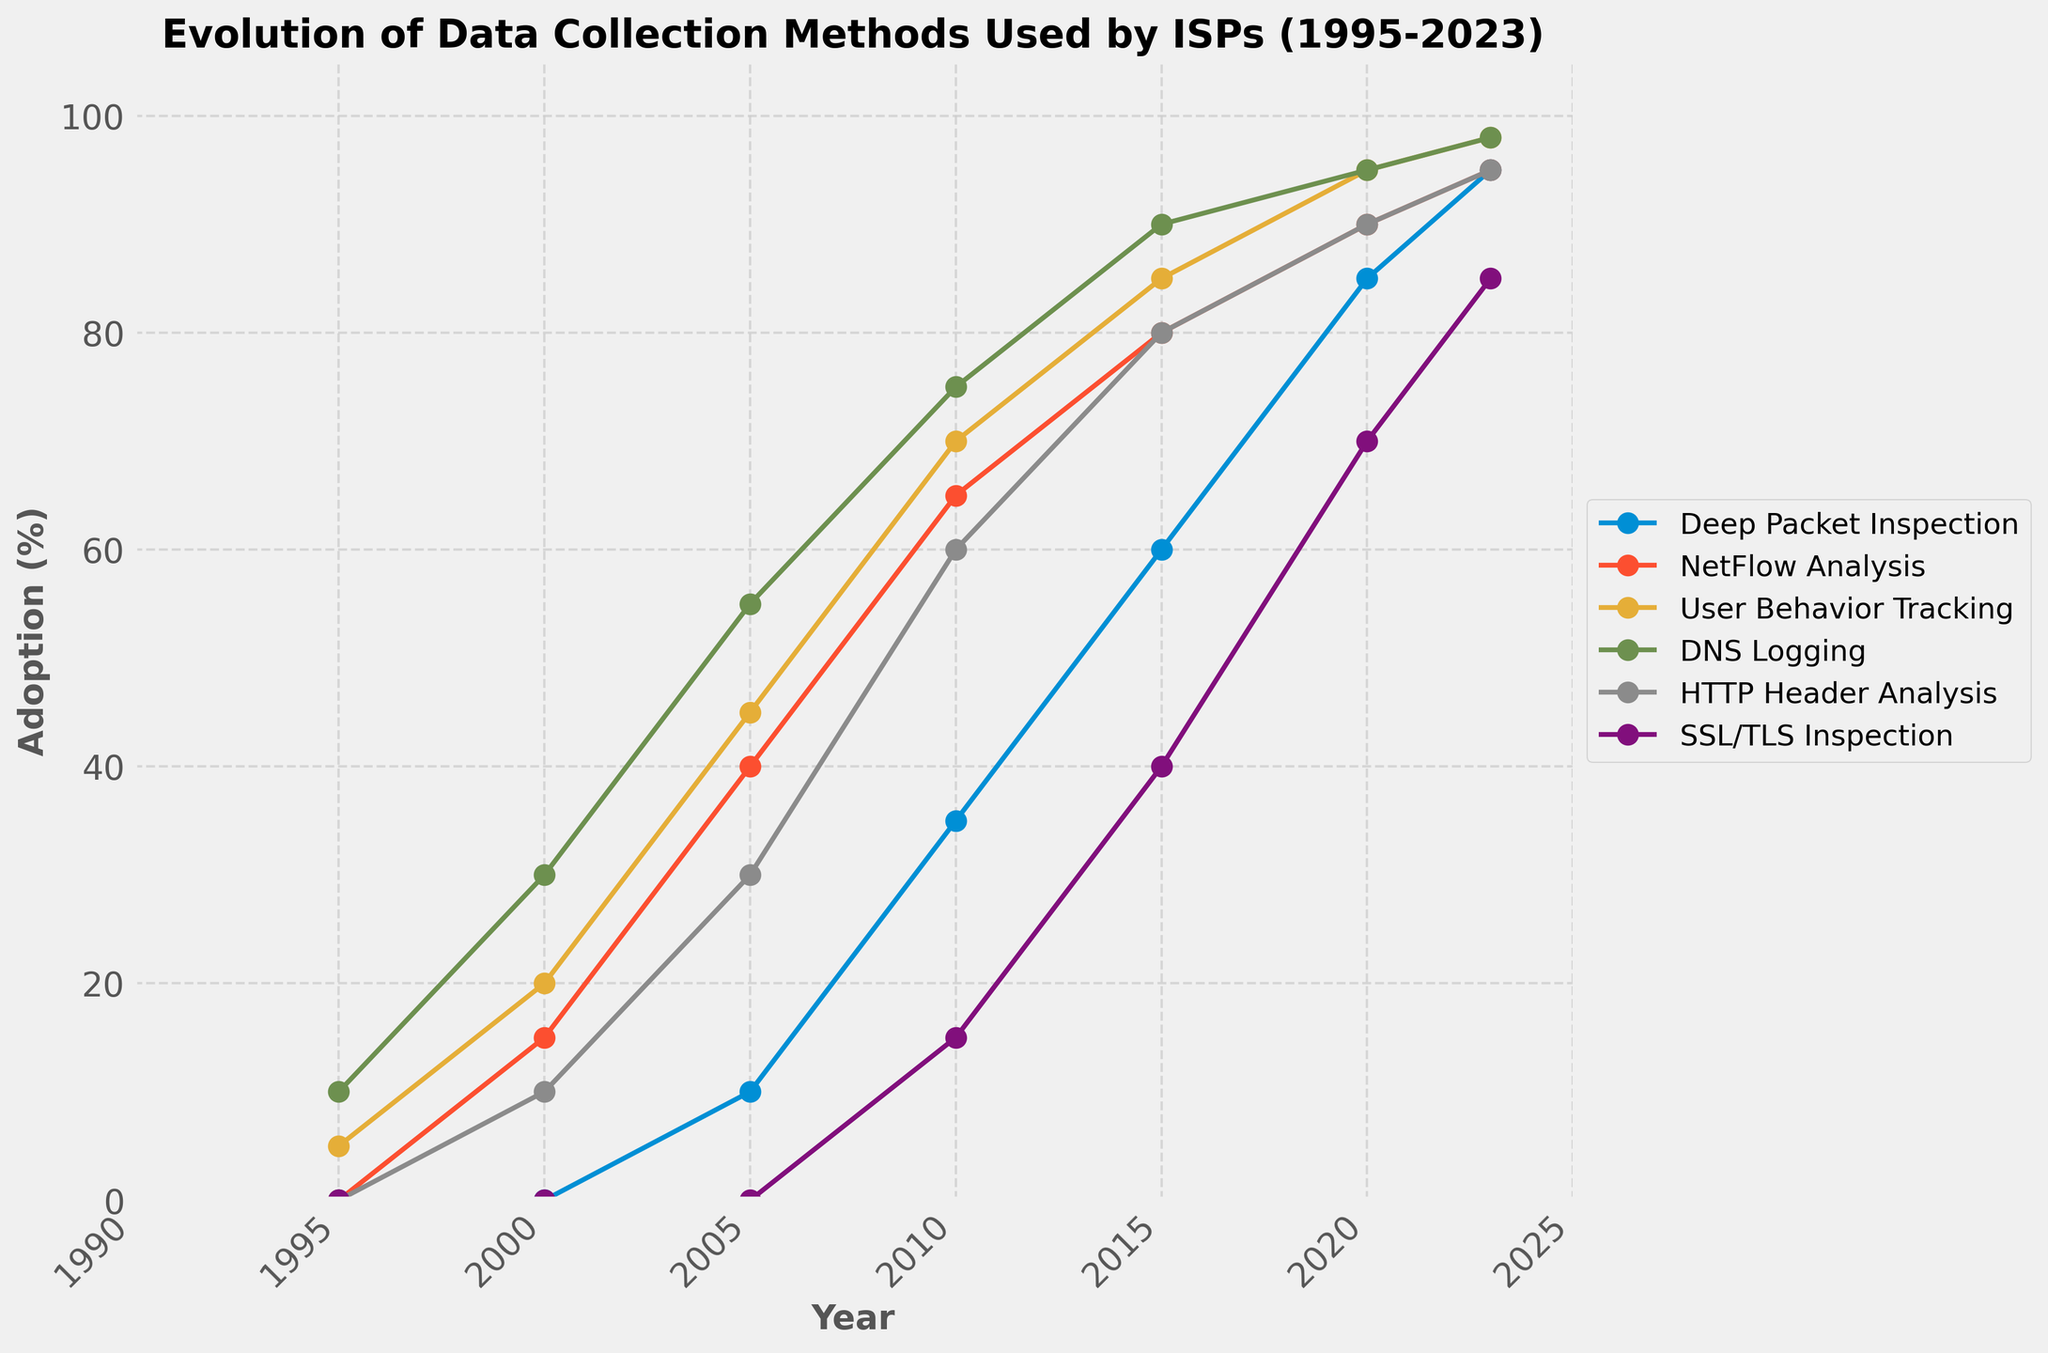What's the overall trend of Deep Packet Inspection from 1995 to 2023? To find the overall trend, observe the line for Deep Packet Inspection on the chart. The percentage starts at 0% in 1995 and increases steadily over time, reaching 95% by 2023.
Answer: Increasing Which data collection method had the highest adoption rate in 2010? Look at the values for each method in 2010 and compare them. Deep Packet Inspection (35%), NetFlow Analysis (65%), User Behavior Tracking (70%), DNS Logging (75%), HTTP Header Analysis (60%), and SSL/TLS Inspection (15%). DNS Logging has the highest adoption rate in 2010 at 75%.
Answer: DNS Logging How does the adoption of SSL/TLS Inspection in 2023 compare to that in 2005? Check the values for SSL/TLS Inspection in 2023 (85%) and 2005 (0%). The adoption significantly increased from 0% in 2005 to 85% in 2023.
Answer: Increased Which method experienced the smallest increase between 2000 and 2005? Calculate the difference for each method from 2000 to 2005: Deep Packet Inspection (10-0=10), NetFlow Analysis (40-15=25), User Behavior Tracking (45-20=25), DNS Logging (55-30=25), HTTP Header Analysis (30-10=20), SSL/TLS Inspection (0-0=0). SSL/TLS Inspection experienced the smallest increase.
Answer: SSL/TLS Inspection By how many percentage points did HTTP Header Analysis increase from 2010 to 2023? Subtract the adoption percentage in 2010 (60%) from that in 2023 (95%) for HTTP Header Analysis. 95% - 60% = 35%
Answer: 35% What's the difference in adoption rate between DNS Logging and User Behavior Tracking in 2020? Look at the values for DNS Logging (95%) and User Behavior Tracking (95%) in 2020. The difference is 95% - 95% = 0%.
Answer: 0% Which method showed the most rapid growth between 1995 and 2023? Calculate the total increase for each method from 1995 to 2023: Deep Packet Inspection (95-0=95), NetFlow Analysis (95-0=95), User Behavior Tracking (98-5=93), DNS Logging (98-10=88), HTTP Header Analysis (95-0=95), SSL/TLS Inspection (85-0=85). Deep Packet Inspection, NetFlow Analysis, and HTTP Header Analysis all have the highest increase of 95 percentage points.
Answer: Deep Packet Inspection, NetFlow Analysis, HTTP Header Analysis Is the adoption of NetFlow Analysis higher in 2015 or 2023? Compare the adoption rates of NetFlow Analysis in 2015 (80%) and 2023 (95%). The adoption rate is higher in 2023.
Answer: 2023 What proportion of the data collection methods reached at least 90% adoption by 2023? Count the methods reaching at least 90% adoption in 2023: Deep Packet Inspection (95%), NetFlow Analysis (95%), User Behavior Tracking (98%), DNS Logging (98%), HTTP Header Analysis (95%), SSL/TLS Inspection (85%). 5 out of 6 methods reached at least 90%. The proportion is 5/6.
Answer: 5/6 